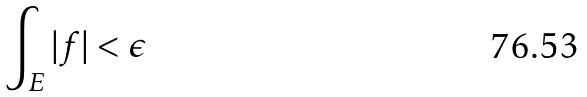Convert formula to latex. <formula><loc_0><loc_0><loc_500><loc_500>\int _ { E } | f | < \epsilon</formula> 